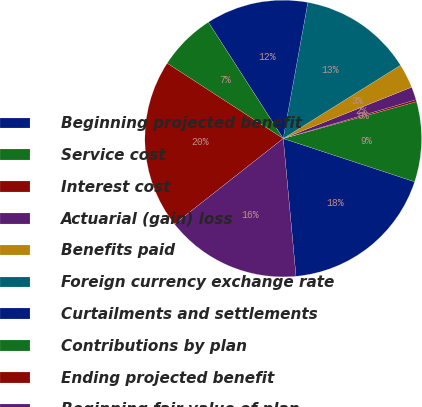Convert chart. <chart><loc_0><loc_0><loc_500><loc_500><pie_chart><fcel>Beginning projected benefit<fcel>Service cost<fcel>Interest cost<fcel>Actuarial (gain) loss<fcel>Benefits paid<fcel>Foreign currency exchange rate<fcel>Curtailments and settlements<fcel>Contributions by plan<fcel>Ending projected benefit<fcel>Beginning fair value of plan<nl><fcel>18.47%<fcel>9.35%<fcel>0.23%<fcel>1.53%<fcel>2.83%<fcel>13.26%<fcel>11.95%<fcel>6.74%<fcel>19.77%<fcel>15.86%<nl></chart> 